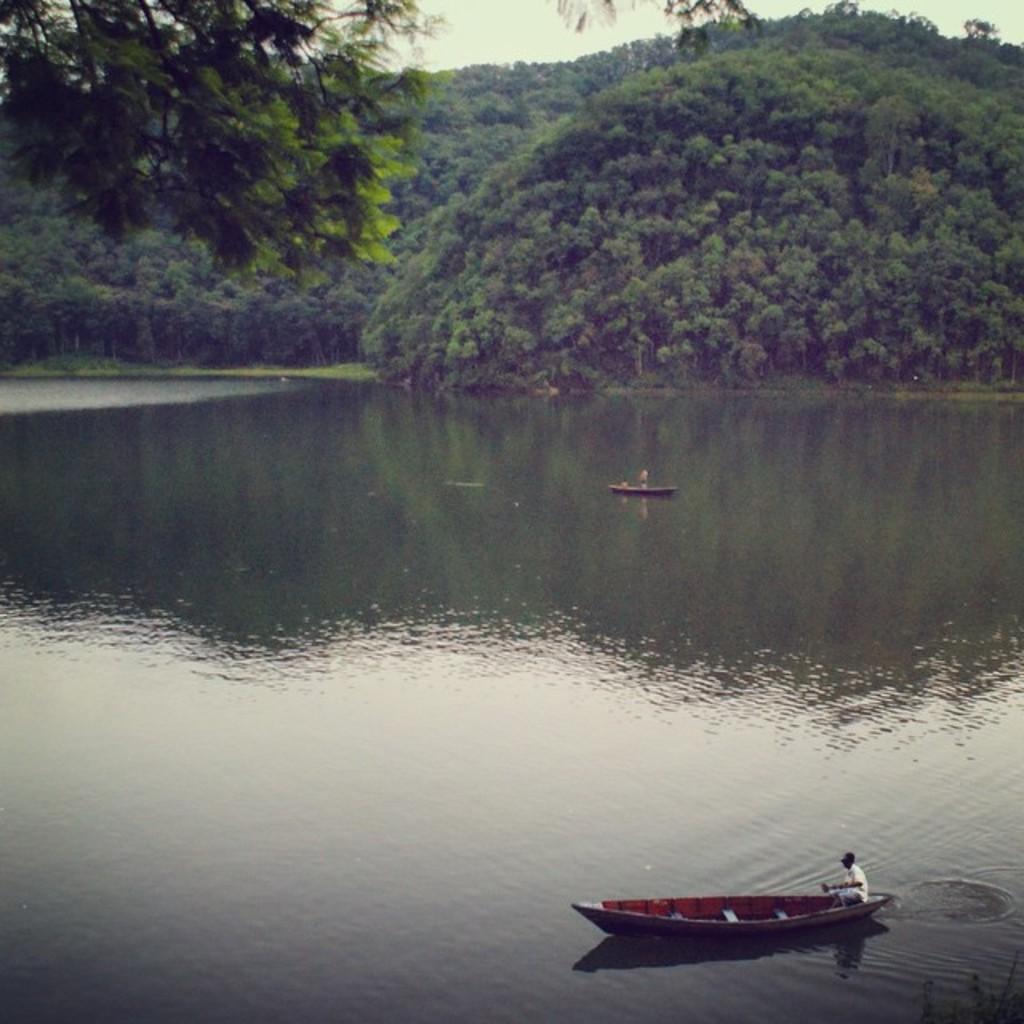Describe this image in one or two sentences. In this picture I can observe a river. There are two boats floating on the water. In the background there are trees and sky. 